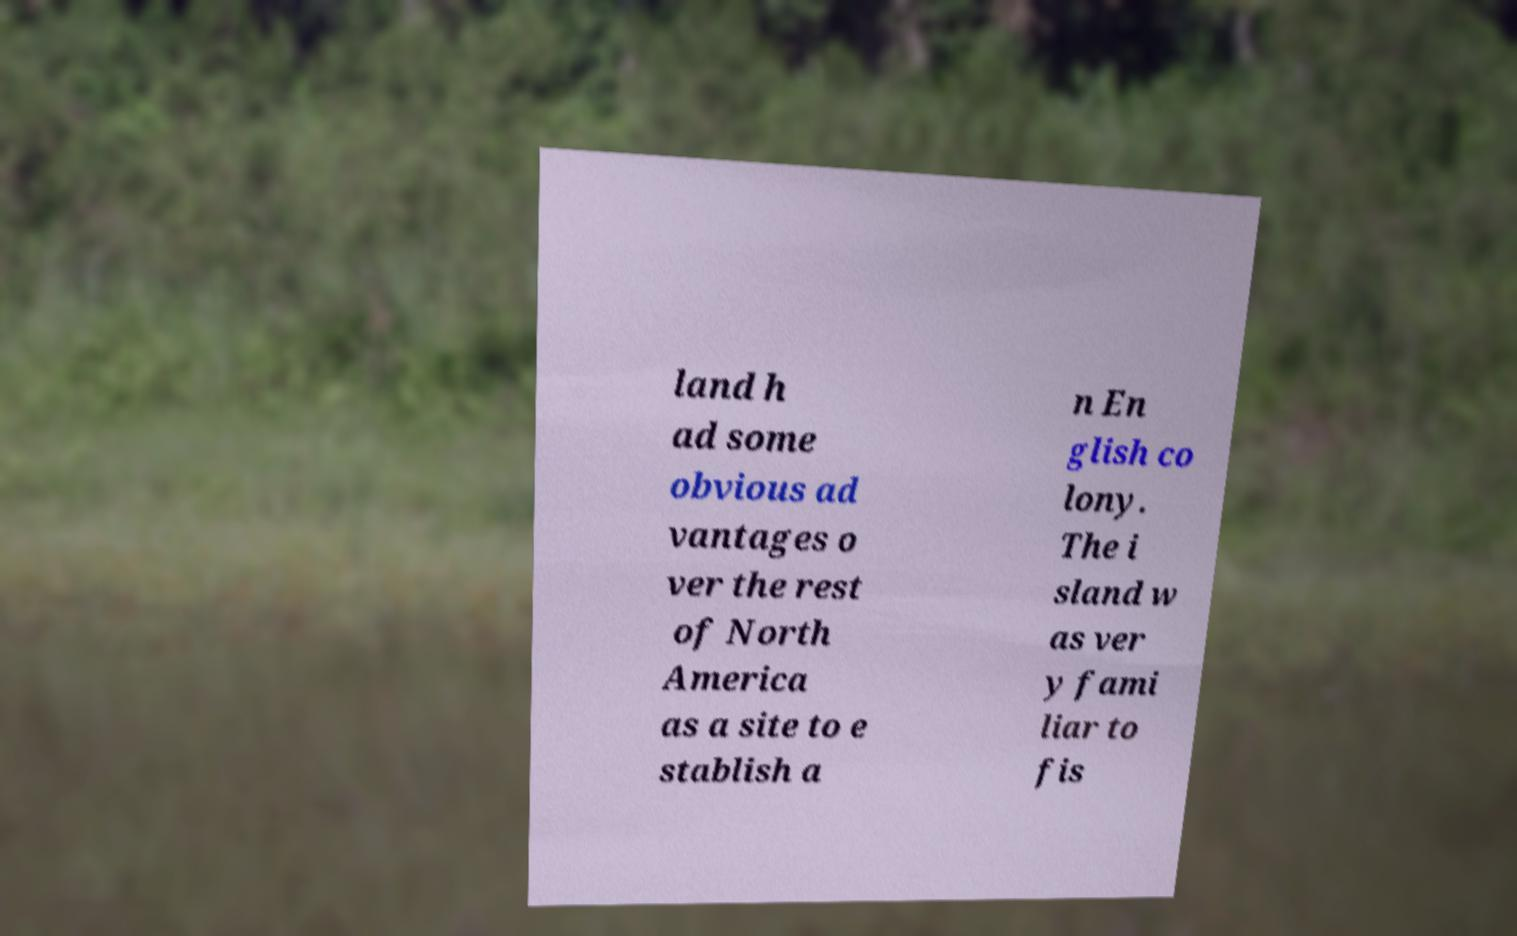Can you accurately transcribe the text from the provided image for me? land h ad some obvious ad vantages o ver the rest of North America as a site to e stablish a n En glish co lony. The i sland w as ver y fami liar to fis 